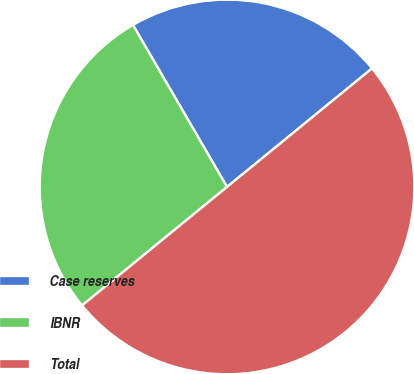Convert chart to OTSL. <chart><loc_0><loc_0><loc_500><loc_500><pie_chart><fcel>Case reserves<fcel>IBNR<fcel>Total<nl><fcel>22.47%<fcel>27.53%<fcel>50.0%<nl></chart> 